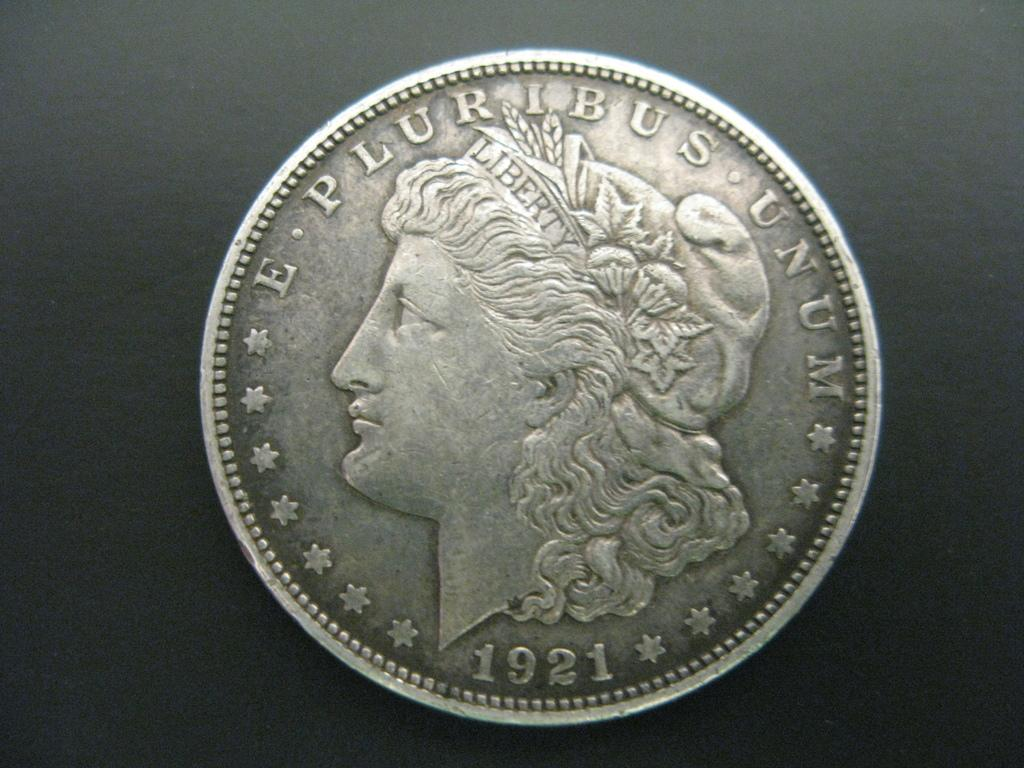<image>
Give a short and clear explanation of the subsequent image. Quarter coin from 1921 from E Puribus Unum 